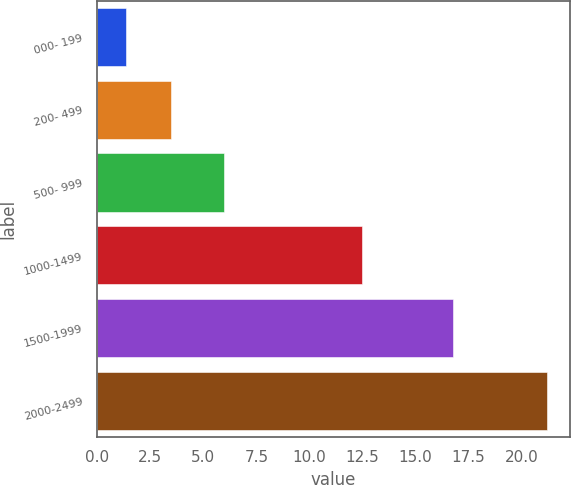<chart> <loc_0><loc_0><loc_500><loc_500><bar_chart><fcel>000- 199<fcel>200- 499<fcel>500- 999<fcel>1000-1499<fcel>1500-1999<fcel>2000-2499<nl><fcel>1.36<fcel>3.5<fcel>5.99<fcel>12.47<fcel>16.78<fcel>21.22<nl></chart> 